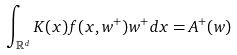<formula> <loc_0><loc_0><loc_500><loc_500>\int _ { \mathbb { R } ^ { d } } K ( x ) f ( x , w ^ { + } ) w ^ { + } d x & = A ^ { + } ( w )</formula> 